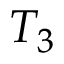<formula> <loc_0><loc_0><loc_500><loc_500>T _ { 3 }</formula> 